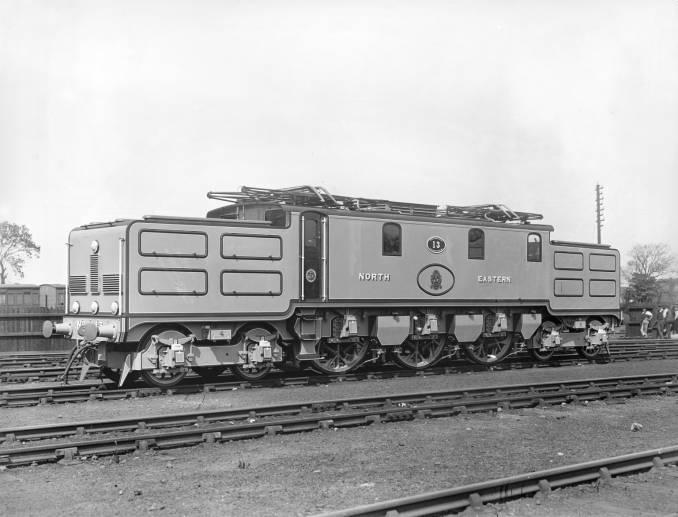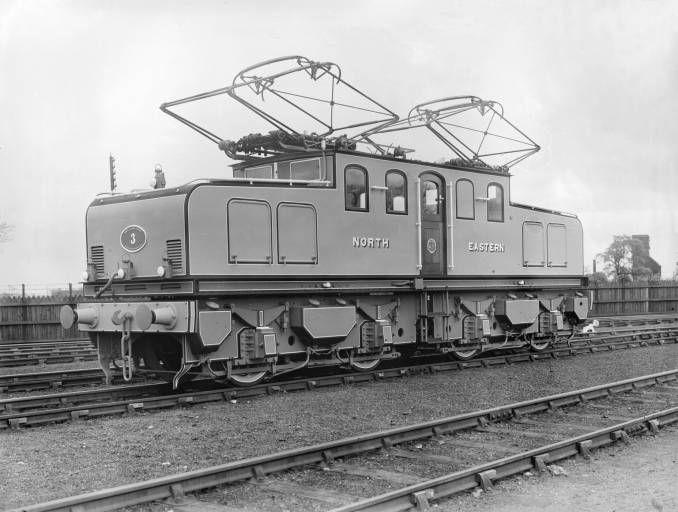The first image is the image on the left, the second image is the image on the right. For the images displayed, is the sentence "There are two trains in total traveling in opposite direction." factually correct? Answer yes or no. No. The first image is the image on the left, the second image is the image on the right. Assess this claim about the two images: "The trains in the left and right images head away from each other, in opposite directions.". Correct or not? Answer yes or no. No. 